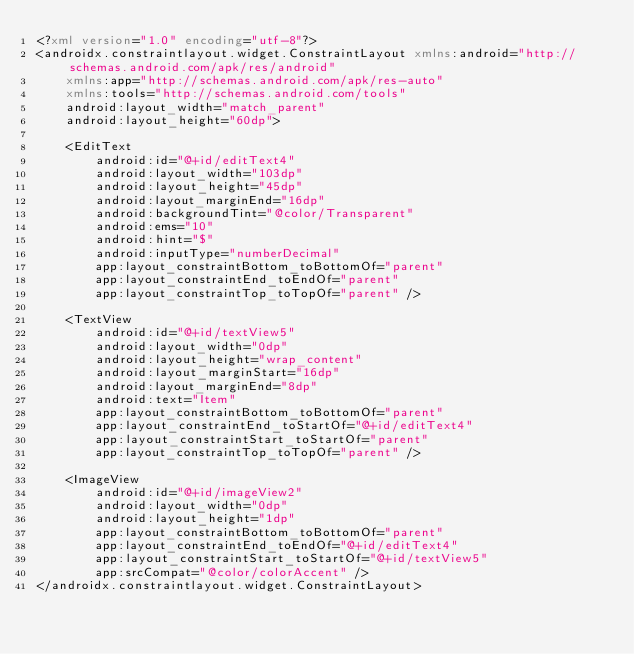Convert code to text. <code><loc_0><loc_0><loc_500><loc_500><_XML_><?xml version="1.0" encoding="utf-8"?>
<androidx.constraintlayout.widget.ConstraintLayout xmlns:android="http://schemas.android.com/apk/res/android"
    xmlns:app="http://schemas.android.com/apk/res-auto"
    xmlns:tools="http://schemas.android.com/tools"
    android:layout_width="match_parent"
    android:layout_height="60dp">

    <EditText
        android:id="@+id/editText4"
        android:layout_width="103dp"
        android:layout_height="45dp"
        android:layout_marginEnd="16dp"
        android:backgroundTint="@color/Transparent"
        android:ems="10"
        android:hint="$"
        android:inputType="numberDecimal"
        app:layout_constraintBottom_toBottomOf="parent"
        app:layout_constraintEnd_toEndOf="parent"
        app:layout_constraintTop_toTopOf="parent" />

    <TextView
        android:id="@+id/textView5"
        android:layout_width="0dp"
        android:layout_height="wrap_content"
        android:layout_marginStart="16dp"
        android:layout_marginEnd="8dp"
        android:text="Item"
        app:layout_constraintBottom_toBottomOf="parent"
        app:layout_constraintEnd_toStartOf="@+id/editText4"
        app:layout_constraintStart_toStartOf="parent"
        app:layout_constraintTop_toTopOf="parent" />

    <ImageView
        android:id="@+id/imageView2"
        android:layout_width="0dp"
        android:layout_height="1dp"
        app:layout_constraintBottom_toBottomOf="parent"
        app:layout_constraintEnd_toEndOf="@+id/editText4"
        app:layout_constraintStart_toStartOf="@+id/textView5"
        app:srcCompat="@color/colorAccent" />
</androidx.constraintlayout.widget.ConstraintLayout></code> 